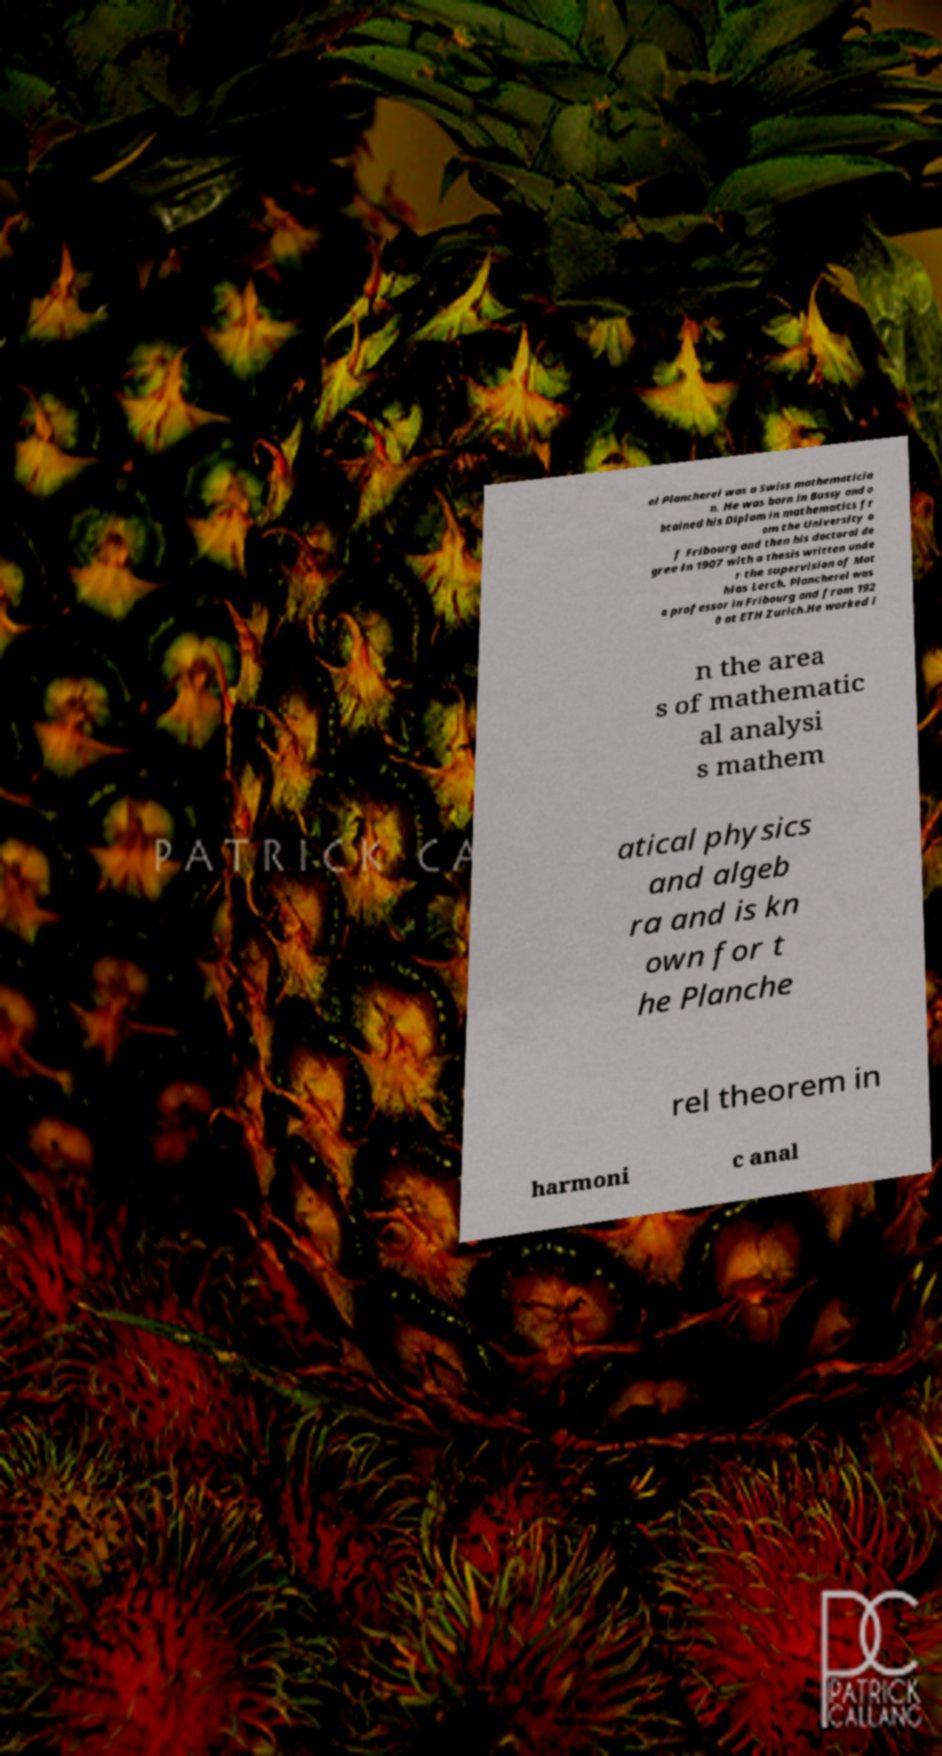Can you accurately transcribe the text from the provided image for me? el Plancherel was a Swiss mathematicia n. He was born in Bussy and o btained his Diplom in mathematics fr om the University o f Fribourg and then his doctoral de gree in 1907 with a thesis written unde r the supervision of Mat hias Lerch. Plancherel was a professor in Fribourg and from 192 0 at ETH Zurich.He worked i n the area s of mathematic al analysi s mathem atical physics and algeb ra and is kn own for t he Planche rel theorem in harmoni c anal 